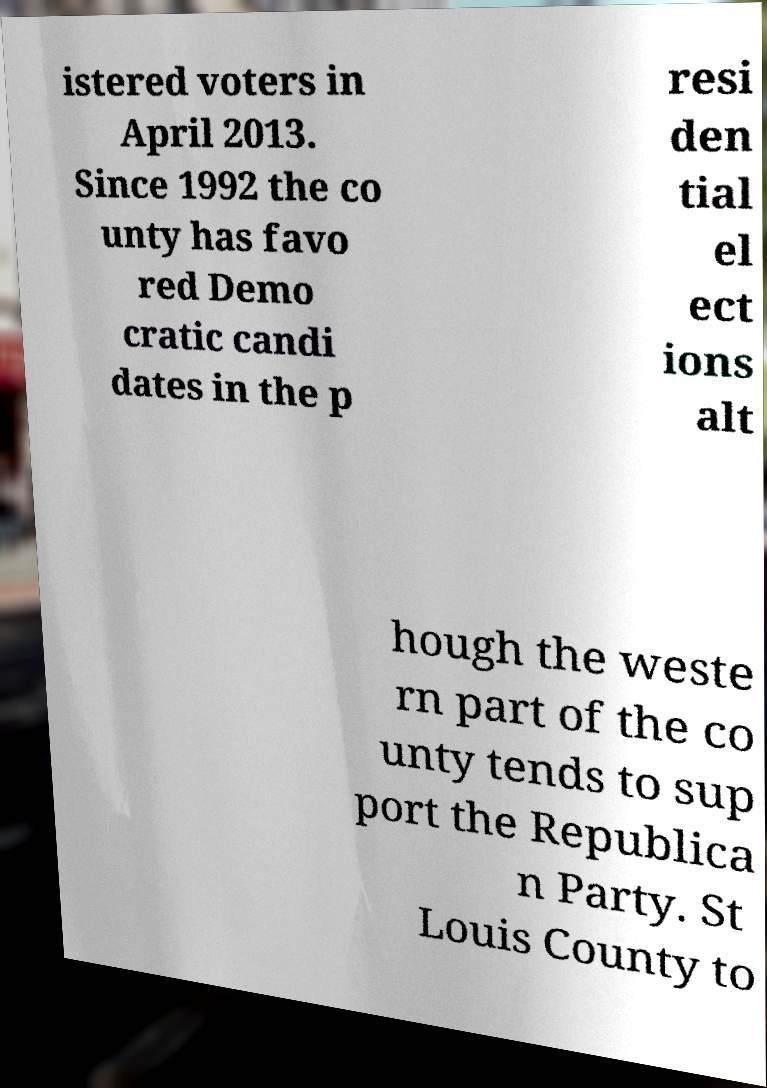I need the written content from this picture converted into text. Can you do that? istered voters in April 2013. Since 1992 the co unty has favo red Demo cratic candi dates in the p resi den tial el ect ions alt hough the weste rn part of the co unty tends to sup port the Republica n Party. St Louis County to 